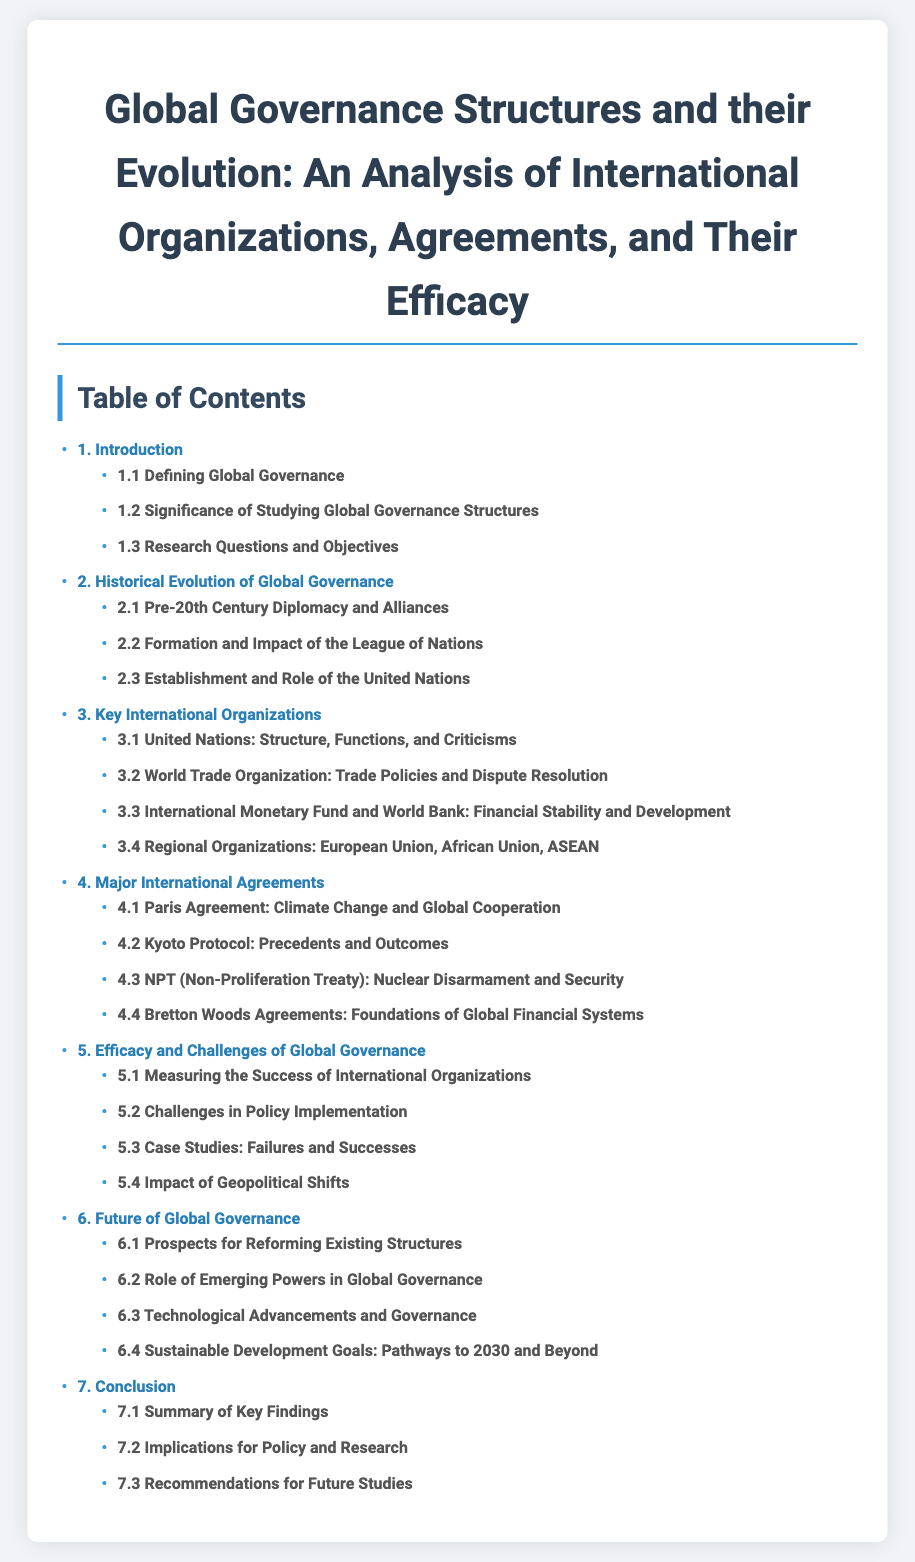what is the title of the document? The title is located at the top of the document and summarizes the main theme.
Answer: Global Governance Structures and their Evolution: An Analysis of International Organizations, Agreements, and Their Efficacy how many chapters are in the Table of Contents? The number of chapters is indicated by the main entries listed in the Table of Contents.
Answer: 7 which chapter discusses the challenges in policy implementation? The chapter numbers and titles indicate which topics are covered under specific headings.
Answer: 5.2 Challenges in Policy Implementation name one major international agreement covered in the document. Specific sections under the Major International Agreements chapter list various agreements discussed in the document.
Answer: Paris Agreement what section addresses the implications for policy and research? The section titles reveal the areas of focus within the conclusion chapter.
Answer: 7.2 Implications for Policy and Research which chapter contains case studies of failures and successes? The chapter titles highlight the main themes of each chapter in the Table of Contents.
Answer: 5.3 Case Studies: Failures and Successes what is the main focus of chapter 6? The chapter title provides insight into the overarching theme discussed within its sections.
Answer: Future of Global Governance which international organization is mentioned in section 3.1? The sections provide specific details about various organizations covered in the document.
Answer: United Nations: Structure, Functions, and Criticisms 